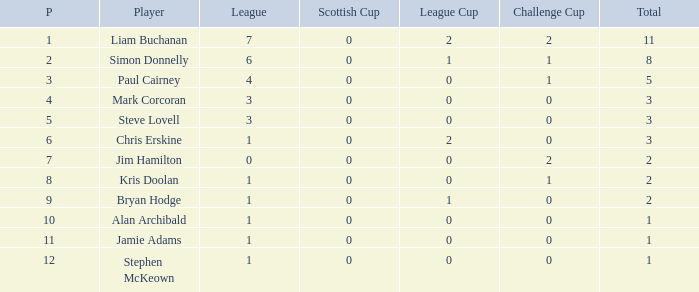Which number is assigned to bryan hodge as a player? 1.0. 